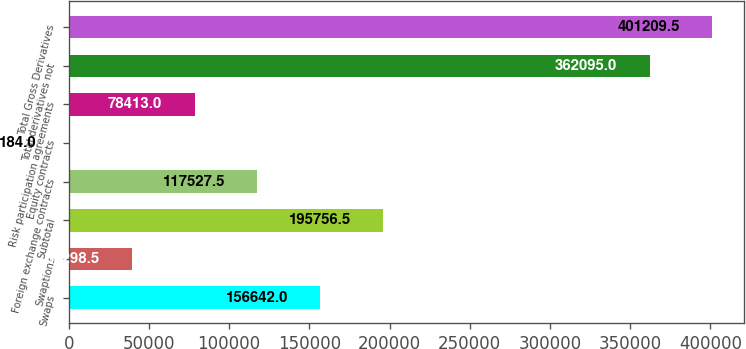Convert chart. <chart><loc_0><loc_0><loc_500><loc_500><bar_chart><fcel>Swaps<fcel>Swaptions<fcel>Subtotal<fcel>Foreign exchange contracts<fcel>Equity contracts<fcel>Risk participation agreements<fcel>Total derivatives not<fcel>Total Gross Derivatives<nl><fcel>156642<fcel>39298.5<fcel>195756<fcel>117528<fcel>184<fcel>78413<fcel>362095<fcel>401210<nl></chart> 